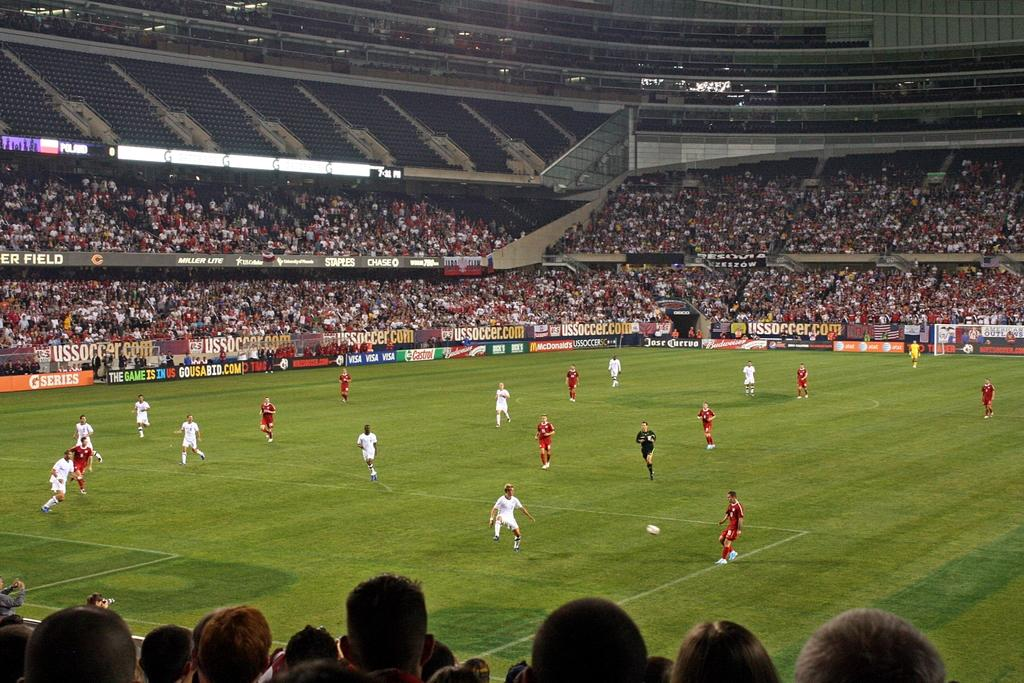<image>
Summarize the visual content of the image. Various advertisements displayed on the walls bordering a soccer field are for companies such as AT&T, Visa and Castrol. 